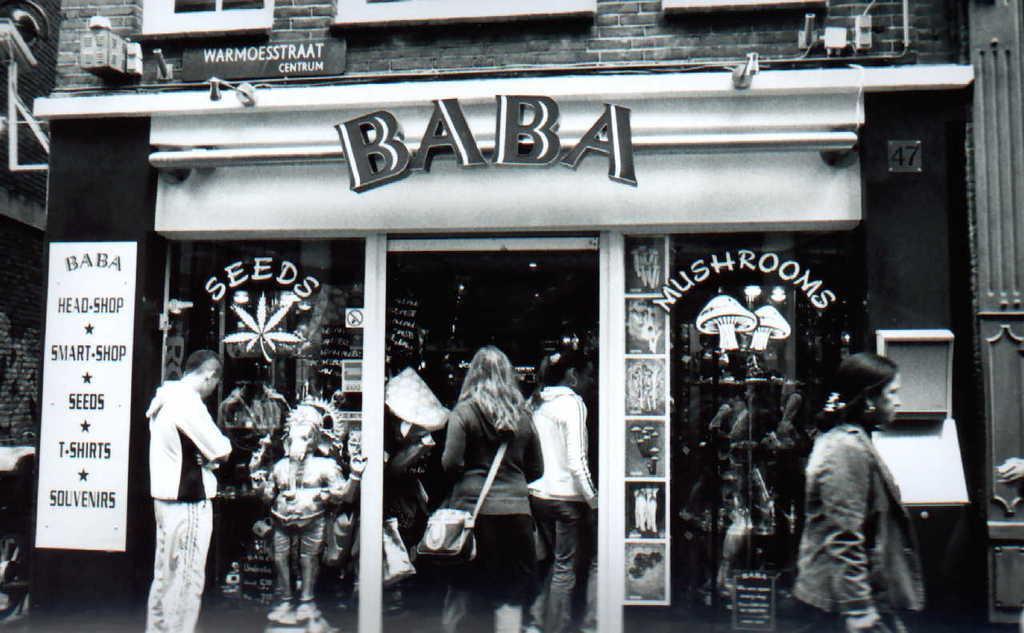Describe this image in one or two sentences. This is a picture of black and white and I can see a building , in front of the building I can see idle and a person visible in front of the building I can see there two women visible entrance gate of the building And I can see a woman on the right side. 